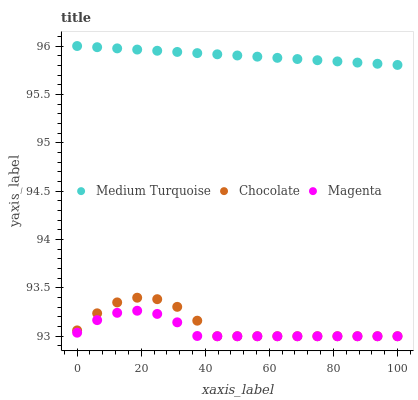Does Magenta have the minimum area under the curve?
Answer yes or no. Yes. Does Medium Turquoise have the maximum area under the curve?
Answer yes or no. Yes. Does Chocolate have the minimum area under the curve?
Answer yes or no. No. Does Chocolate have the maximum area under the curve?
Answer yes or no. No. Is Medium Turquoise the smoothest?
Answer yes or no. Yes. Is Chocolate the roughest?
Answer yes or no. Yes. Is Chocolate the smoothest?
Answer yes or no. No. Is Medium Turquoise the roughest?
Answer yes or no. No. Does Magenta have the lowest value?
Answer yes or no. Yes. Does Medium Turquoise have the lowest value?
Answer yes or no. No. Does Medium Turquoise have the highest value?
Answer yes or no. Yes. Does Chocolate have the highest value?
Answer yes or no. No. Is Chocolate less than Medium Turquoise?
Answer yes or no. Yes. Is Medium Turquoise greater than Magenta?
Answer yes or no. Yes. Does Magenta intersect Chocolate?
Answer yes or no. Yes. Is Magenta less than Chocolate?
Answer yes or no. No. Is Magenta greater than Chocolate?
Answer yes or no. No. Does Chocolate intersect Medium Turquoise?
Answer yes or no. No. 